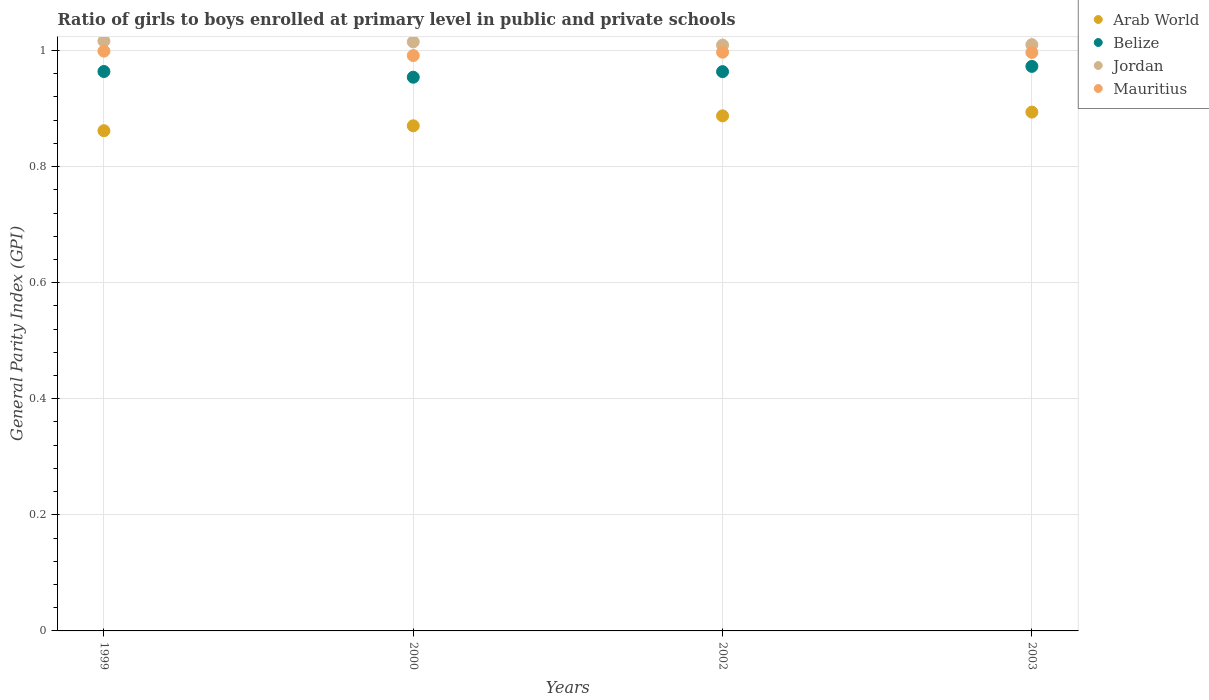Is the number of dotlines equal to the number of legend labels?
Offer a terse response. Yes. What is the general parity index in Belize in 2000?
Make the answer very short. 0.95. Across all years, what is the maximum general parity index in Arab World?
Offer a very short reply. 0.89. Across all years, what is the minimum general parity index in Mauritius?
Your answer should be very brief. 0.99. In which year was the general parity index in Arab World maximum?
Provide a short and direct response. 2003. In which year was the general parity index in Belize minimum?
Offer a very short reply. 2000. What is the total general parity index in Belize in the graph?
Make the answer very short. 3.85. What is the difference between the general parity index in Belize in 1999 and that in 2000?
Keep it short and to the point. 0.01. What is the difference between the general parity index in Jordan in 2002 and the general parity index in Arab World in 1999?
Make the answer very short. 0.15. What is the average general parity index in Belize per year?
Offer a very short reply. 0.96. In the year 1999, what is the difference between the general parity index in Belize and general parity index in Arab World?
Your answer should be compact. 0.1. In how many years, is the general parity index in Belize greater than 0.6400000000000001?
Your answer should be compact. 4. What is the ratio of the general parity index in Jordan in 2000 to that in 2002?
Offer a very short reply. 1.01. Is the difference between the general parity index in Belize in 1999 and 2002 greater than the difference between the general parity index in Arab World in 1999 and 2002?
Your answer should be very brief. Yes. What is the difference between the highest and the second highest general parity index in Jordan?
Your answer should be very brief. 0. What is the difference between the highest and the lowest general parity index in Mauritius?
Offer a terse response. 0.01. Is it the case that in every year, the sum of the general parity index in Mauritius and general parity index in Arab World  is greater than the general parity index in Jordan?
Your response must be concise. Yes. Is the general parity index in Belize strictly less than the general parity index in Mauritius over the years?
Keep it short and to the point. Yes. How many years are there in the graph?
Keep it short and to the point. 4. Does the graph contain grids?
Your answer should be compact. Yes. Where does the legend appear in the graph?
Your answer should be compact. Top right. How are the legend labels stacked?
Provide a succinct answer. Vertical. What is the title of the graph?
Your answer should be very brief. Ratio of girls to boys enrolled at primary level in public and private schools. What is the label or title of the Y-axis?
Provide a succinct answer. General Parity Index (GPI). What is the General Parity Index (GPI) of Arab World in 1999?
Ensure brevity in your answer.  0.86. What is the General Parity Index (GPI) of Belize in 1999?
Ensure brevity in your answer.  0.96. What is the General Parity Index (GPI) of Jordan in 1999?
Your answer should be very brief. 1.02. What is the General Parity Index (GPI) of Mauritius in 1999?
Ensure brevity in your answer.  1. What is the General Parity Index (GPI) of Arab World in 2000?
Keep it short and to the point. 0.87. What is the General Parity Index (GPI) of Belize in 2000?
Provide a succinct answer. 0.95. What is the General Parity Index (GPI) in Jordan in 2000?
Your response must be concise. 1.01. What is the General Parity Index (GPI) of Mauritius in 2000?
Your answer should be compact. 0.99. What is the General Parity Index (GPI) in Arab World in 2002?
Keep it short and to the point. 0.89. What is the General Parity Index (GPI) of Belize in 2002?
Offer a terse response. 0.96. What is the General Parity Index (GPI) in Jordan in 2002?
Offer a terse response. 1.01. What is the General Parity Index (GPI) in Mauritius in 2002?
Make the answer very short. 1. What is the General Parity Index (GPI) of Arab World in 2003?
Offer a very short reply. 0.89. What is the General Parity Index (GPI) of Belize in 2003?
Provide a short and direct response. 0.97. What is the General Parity Index (GPI) in Jordan in 2003?
Provide a short and direct response. 1.01. What is the General Parity Index (GPI) in Mauritius in 2003?
Keep it short and to the point. 1. Across all years, what is the maximum General Parity Index (GPI) in Arab World?
Provide a succinct answer. 0.89. Across all years, what is the maximum General Parity Index (GPI) in Belize?
Keep it short and to the point. 0.97. Across all years, what is the maximum General Parity Index (GPI) in Jordan?
Provide a succinct answer. 1.02. Across all years, what is the maximum General Parity Index (GPI) in Mauritius?
Your answer should be compact. 1. Across all years, what is the minimum General Parity Index (GPI) of Arab World?
Provide a succinct answer. 0.86. Across all years, what is the minimum General Parity Index (GPI) of Belize?
Provide a short and direct response. 0.95. Across all years, what is the minimum General Parity Index (GPI) of Jordan?
Your answer should be very brief. 1.01. Across all years, what is the minimum General Parity Index (GPI) of Mauritius?
Your answer should be very brief. 0.99. What is the total General Parity Index (GPI) of Arab World in the graph?
Give a very brief answer. 3.51. What is the total General Parity Index (GPI) of Belize in the graph?
Your response must be concise. 3.85. What is the total General Parity Index (GPI) in Jordan in the graph?
Offer a terse response. 4.05. What is the total General Parity Index (GPI) in Mauritius in the graph?
Ensure brevity in your answer.  3.98. What is the difference between the General Parity Index (GPI) in Arab World in 1999 and that in 2000?
Make the answer very short. -0.01. What is the difference between the General Parity Index (GPI) of Belize in 1999 and that in 2000?
Make the answer very short. 0.01. What is the difference between the General Parity Index (GPI) in Jordan in 1999 and that in 2000?
Make the answer very short. 0. What is the difference between the General Parity Index (GPI) in Mauritius in 1999 and that in 2000?
Your answer should be compact. 0.01. What is the difference between the General Parity Index (GPI) in Arab World in 1999 and that in 2002?
Provide a short and direct response. -0.03. What is the difference between the General Parity Index (GPI) in Belize in 1999 and that in 2002?
Keep it short and to the point. 0. What is the difference between the General Parity Index (GPI) in Jordan in 1999 and that in 2002?
Offer a terse response. 0.01. What is the difference between the General Parity Index (GPI) in Mauritius in 1999 and that in 2002?
Ensure brevity in your answer.  0. What is the difference between the General Parity Index (GPI) of Arab World in 1999 and that in 2003?
Offer a terse response. -0.03. What is the difference between the General Parity Index (GPI) in Belize in 1999 and that in 2003?
Your answer should be compact. -0.01. What is the difference between the General Parity Index (GPI) of Jordan in 1999 and that in 2003?
Your response must be concise. 0.01. What is the difference between the General Parity Index (GPI) in Mauritius in 1999 and that in 2003?
Offer a very short reply. 0. What is the difference between the General Parity Index (GPI) in Arab World in 2000 and that in 2002?
Keep it short and to the point. -0.02. What is the difference between the General Parity Index (GPI) of Belize in 2000 and that in 2002?
Provide a succinct answer. -0.01. What is the difference between the General Parity Index (GPI) in Jordan in 2000 and that in 2002?
Give a very brief answer. 0.01. What is the difference between the General Parity Index (GPI) of Mauritius in 2000 and that in 2002?
Make the answer very short. -0.01. What is the difference between the General Parity Index (GPI) of Arab World in 2000 and that in 2003?
Provide a short and direct response. -0.02. What is the difference between the General Parity Index (GPI) of Belize in 2000 and that in 2003?
Keep it short and to the point. -0.02. What is the difference between the General Parity Index (GPI) in Jordan in 2000 and that in 2003?
Give a very brief answer. 0. What is the difference between the General Parity Index (GPI) in Mauritius in 2000 and that in 2003?
Make the answer very short. -0.01. What is the difference between the General Parity Index (GPI) in Arab World in 2002 and that in 2003?
Offer a terse response. -0.01. What is the difference between the General Parity Index (GPI) of Belize in 2002 and that in 2003?
Provide a succinct answer. -0.01. What is the difference between the General Parity Index (GPI) of Jordan in 2002 and that in 2003?
Ensure brevity in your answer.  -0. What is the difference between the General Parity Index (GPI) of Mauritius in 2002 and that in 2003?
Offer a terse response. 0. What is the difference between the General Parity Index (GPI) in Arab World in 1999 and the General Parity Index (GPI) in Belize in 2000?
Ensure brevity in your answer.  -0.09. What is the difference between the General Parity Index (GPI) in Arab World in 1999 and the General Parity Index (GPI) in Jordan in 2000?
Provide a succinct answer. -0.15. What is the difference between the General Parity Index (GPI) of Arab World in 1999 and the General Parity Index (GPI) of Mauritius in 2000?
Keep it short and to the point. -0.13. What is the difference between the General Parity Index (GPI) in Belize in 1999 and the General Parity Index (GPI) in Jordan in 2000?
Your answer should be very brief. -0.05. What is the difference between the General Parity Index (GPI) in Belize in 1999 and the General Parity Index (GPI) in Mauritius in 2000?
Give a very brief answer. -0.03. What is the difference between the General Parity Index (GPI) of Jordan in 1999 and the General Parity Index (GPI) of Mauritius in 2000?
Keep it short and to the point. 0.03. What is the difference between the General Parity Index (GPI) of Arab World in 1999 and the General Parity Index (GPI) of Belize in 2002?
Make the answer very short. -0.1. What is the difference between the General Parity Index (GPI) in Arab World in 1999 and the General Parity Index (GPI) in Jordan in 2002?
Keep it short and to the point. -0.15. What is the difference between the General Parity Index (GPI) of Arab World in 1999 and the General Parity Index (GPI) of Mauritius in 2002?
Offer a very short reply. -0.14. What is the difference between the General Parity Index (GPI) in Belize in 1999 and the General Parity Index (GPI) in Jordan in 2002?
Give a very brief answer. -0.05. What is the difference between the General Parity Index (GPI) of Belize in 1999 and the General Parity Index (GPI) of Mauritius in 2002?
Offer a very short reply. -0.03. What is the difference between the General Parity Index (GPI) in Jordan in 1999 and the General Parity Index (GPI) in Mauritius in 2002?
Offer a terse response. 0.02. What is the difference between the General Parity Index (GPI) of Arab World in 1999 and the General Parity Index (GPI) of Belize in 2003?
Keep it short and to the point. -0.11. What is the difference between the General Parity Index (GPI) of Arab World in 1999 and the General Parity Index (GPI) of Jordan in 2003?
Give a very brief answer. -0.15. What is the difference between the General Parity Index (GPI) of Arab World in 1999 and the General Parity Index (GPI) of Mauritius in 2003?
Ensure brevity in your answer.  -0.13. What is the difference between the General Parity Index (GPI) of Belize in 1999 and the General Parity Index (GPI) of Jordan in 2003?
Your answer should be very brief. -0.05. What is the difference between the General Parity Index (GPI) of Belize in 1999 and the General Parity Index (GPI) of Mauritius in 2003?
Ensure brevity in your answer.  -0.03. What is the difference between the General Parity Index (GPI) of Jordan in 1999 and the General Parity Index (GPI) of Mauritius in 2003?
Give a very brief answer. 0.02. What is the difference between the General Parity Index (GPI) of Arab World in 2000 and the General Parity Index (GPI) of Belize in 2002?
Your answer should be very brief. -0.09. What is the difference between the General Parity Index (GPI) in Arab World in 2000 and the General Parity Index (GPI) in Jordan in 2002?
Provide a succinct answer. -0.14. What is the difference between the General Parity Index (GPI) of Arab World in 2000 and the General Parity Index (GPI) of Mauritius in 2002?
Keep it short and to the point. -0.13. What is the difference between the General Parity Index (GPI) of Belize in 2000 and the General Parity Index (GPI) of Jordan in 2002?
Make the answer very short. -0.06. What is the difference between the General Parity Index (GPI) in Belize in 2000 and the General Parity Index (GPI) in Mauritius in 2002?
Give a very brief answer. -0.04. What is the difference between the General Parity Index (GPI) of Jordan in 2000 and the General Parity Index (GPI) of Mauritius in 2002?
Give a very brief answer. 0.02. What is the difference between the General Parity Index (GPI) of Arab World in 2000 and the General Parity Index (GPI) of Belize in 2003?
Make the answer very short. -0.1. What is the difference between the General Parity Index (GPI) in Arab World in 2000 and the General Parity Index (GPI) in Jordan in 2003?
Offer a terse response. -0.14. What is the difference between the General Parity Index (GPI) of Arab World in 2000 and the General Parity Index (GPI) of Mauritius in 2003?
Provide a succinct answer. -0.13. What is the difference between the General Parity Index (GPI) of Belize in 2000 and the General Parity Index (GPI) of Jordan in 2003?
Your answer should be compact. -0.06. What is the difference between the General Parity Index (GPI) of Belize in 2000 and the General Parity Index (GPI) of Mauritius in 2003?
Your answer should be very brief. -0.04. What is the difference between the General Parity Index (GPI) of Jordan in 2000 and the General Parity Index (GPI) of Mauritius in 2003?
Ensure brevity in your answer.  0.02. What is the difference between the General Parity Index (GPI) in Arab World in 2002 and the General Parity Index (GPI) in Belize in 2003?
Give a very brief answer. -0.09. What is the difference between the General Parity Index (GPI) of Arab World in 2002 and the General Parity Index (GPI) of Jordan in 2003?
Give a very brief answer. -0.12. What is the difference between the General Parity Index (GPI) of Arab World in 2002 and the General Parity Index (GPI) of Mauritius in 2003?
Your answer should be compact. -0.11. What is the difference between the General Parity Index (GPI) of Belize in 2002 and the General Parity Index (GPI) of Jordan in 2003?
Provide a short and direct response. -0.05. What is the difference between the General Parity Index (GPI) of Belize in 2002 and the General Parity Index (GPI) of Mauritius in 2003?
Keep it short and to the point. -0.03. What is the difference between the General Parity Index (GPI) of Jordan in 2002 and the General Parity Index (GPI) of Mauritius in 2003?
Ensure brevity in your answer.  0.01. What is the average General Parity Index (GPI) of Arab World per year?
Provide a succinct answer. 0.88. What is the average General Parity Index (GPI) in Belize per year?
Give a very brief answer. 0.96. What is the average General Parity Index (GPI) of Jordan per year?
Provide a short and direct response. 1.01. In the year 1999, what is the difference between the General Parity Index (GPI) of Arab World and General Parity Index (GPI) of Belize?
Ensure brevity in your answer.  -0.1. In the year 1999, what is the difference between the General Parity Index (GPI) in Arab World and General Parity Index (GPI) in Jordan?
Make the answer very short. -0.15. In the year 1999, what is the difference between the General Parity Index (GPI) in Arab World and General Parity Index (GPI) in Mauritius?
Provide a succinct answer. -0.14. In the year 1999, what is the difference between the General Parity Index (GPI) in Belize and General Parity Index (GPI) in Jordan?
Offer a very short reply. -0.05. In the year 1999, what is the difference between the General Parity Index (GPI) in Belize and General Parity Index (GPI) in Mauritius?
Ensure brevity in your answer.  -0.04. In the year 1999, what is the difference between the General Parity Index (GPI) in Jordan and General Parity Index (GPI) in Mauritius?
Offer a very short reply. 0.02. In the year 2000, what is the difference between the General Parity Index (GPI) in Arab World and General Parity Index (GPI) in Belize?
Provide a succinct answer. -0.08. In the year 2000, what is the difference between the General Parity Index (GPI) in Arab World and General Parity Index (GPI) in Jordan?
Provide a short and direct response. -0.14. In the year 2000, what is the difference between the General Parity Index (GPI) in Arab World and General Parity Index (GPI) in Mauritius?
Give a very brief answer. -0.12. In the year 2000, what is the difference between the General Parity Index (GPI) in Belize and General Parity Index (GPI) in Jordan?
Give a very brief answer. -0.06. In the year 2000, what is the difference between the General Parity Index (GPI) in Belize and General Parity Index (GPI) in Mauritius?
Your response must be concise. -0.04. In the year 2000, what is the difference between the General Parity Index (GPI) of Jordan and General Parity Index (GPI) of Mauritius?
Your answer should be very brief. 0.02. In the year 2002, what is the difference between the General Parity Index (GPI) in Arab World and General Parity Index (GPI) in Belize?
Make the answer very short. -0.08. In the year 2002, what is the difference between the General Parity Index (GPI) in Arab World and General Parity Index (GPI) in Jordan?
Your answer should be very brief. -0.12. In the year 2002, what is the difference between the General Parity Index (GPI) of Arab World and General Parity Index (GPI) of Mauritius?
Provide a short and direct response. -0.11. In the year 2002, what is the difference between the General Parity Index (GPI) of Belize and General Parity Index (GPI) of Jordan?
Your answer should be compact. -0.05. In the year 2002, what is the difference between the General Parity Index (GPI) of Belize and General Parity Index (GPI) of Mauritius?
Make the answer very short. -0.03. In the year 2002, what is the difference between the General Parity Index (GPI) of Jordan and General Parity Index (GPI) of Mauritius?
Offer a very short reply. 0.01. In the year 2003, what is the difference between the General Parity Index (GPI) in Arab World and General Parity Index (GPI) in Belize?
Offer a terse response. -0.08. In the year 2003, what is the difference between the General Parity Index (GPI) of Arab World and General Parity Index (GPI) of Jordan?
Give a very brief answer. -0.12. In the year 2003, what is the difference between the General Parity Index (GPI) of Arab World and General Parity Index (GPI) of Mauritius?
Offer a very short reply. -0.1. In the year 2003, what is the difference between the General Parity Index (GPI) in Belize and General Parity Index (GPI) in Jordan?
Your answer should be compact. -0.04. In the year 2003, what is the difference between the General Parity Index (GPI) in Belize and General Parity Index (GPI) in Mauritius?
Keep it short and to the point. -0.02. In the year 2003, what is the difference between the General Parity Index (GPI) in Jordan and General Parity Index (GPI) in Mauritius?
Offer a very short reply. 0.01. What is the ratio of the General Parity Index (GPI) in Arab World in 1999 to that in 2000?
Offer a terse response. 0.99. What is the ratio of the General Parity Index (GPI) of Belize in 1999 to that in 2000?
Your answer should be very brief. 1.01. What is the ratio of the General Parity Index (GPI) of Mauritius in 1999 to that in 2000?
Keep it short and to the point. 1.01. What is the ratio of the General Parity Index (GPI) of Arab World in 1999 to that in 2002?
Offer a very short reply. 0.97. What is the ratio of the General Parity Index (GPI) in Arab World in 1999 to that in 2003?
Your answer should be compact. 0.96. What is the ratio of the General Parity Index (GPI) in Belize in 1999 to that in 2003?
Ensure brevity in your answer.  0.99. What is the ratio of the General Parity Index (GPI) of Jordan in 1999 to that in 2003?
Provide a succinct answer. 1.01. What is the ratio of the General Parity Index (GPI) of Arab World in 2000 to that in 2002?
Give a very brief answer. 0.98. What is the ratio of the General Parity Index (GPI) of Belize in 2000 to that in 2002?
Provide a short and direct response. 0.99. What is the ratio of the General Parity Index (GPI) of Jordan in 2000 to that in 2002?
Ensure brevity in your answer.  1.01. What is the ratio of the General Parity Index (GPI) in Mauritius in 2000 to that in 2002?
Your response must be concise. 0.99. What is the ratio of the General Parity Index (GPI) in Arab World in 2000 to that in 2003?
Your response must be concise. 0.97. What is the ratio of the General Parity Index (GPI) of Belize in 2000 to that in 2003?
Offer a very short reply. 0.98. What is the ratio of the General Parity Index (GPI) of Mauritius in 2000 to that in 2003?
Keep it short and to the point. 0.99. What is the ratio of the General Parity Index (GPI) in Jordan in 2002 to that in 2003?
Provide a succinct answer. 1. What is the ratio of the General Parity Index (GPI) in Mauritius in 2002 to that in 2003?
Ensure brevity in your answer.  1. What is the difference between the highest and the second highest General Parity Index (GPI) in Arab World?
Provide a succinct answer. 0.01. What is the difference between the highest and the second highest General Parity Index (GPI) in Belize?
Your answer should be very brief. 0.01. What is the difference between the highest and the second highest General Parity Index (GPI) in Jordan?
Offer a terse response. 0. What is the difference between the highest and the second highest General Parity Index (GPI) of Mauritius?
Make the answer very short. 0. What is the difference between the highest and the lowest General Parity Index (GPI) in Arab World?
Provide a succinct answer. 0.03. What is the difference between the highest and the lowest General Parity Index (GPI) in Belize?
Make the answer very short. 0.02. What is the difference between the highest and the lowest General Parity Index (GPI) in Jordan?
Your answer should be very brief. 0.01. What is the difference between the highest and the lowest General Parity Index (GPI) in Mauritius?
Your response must be concise. 0.01. 